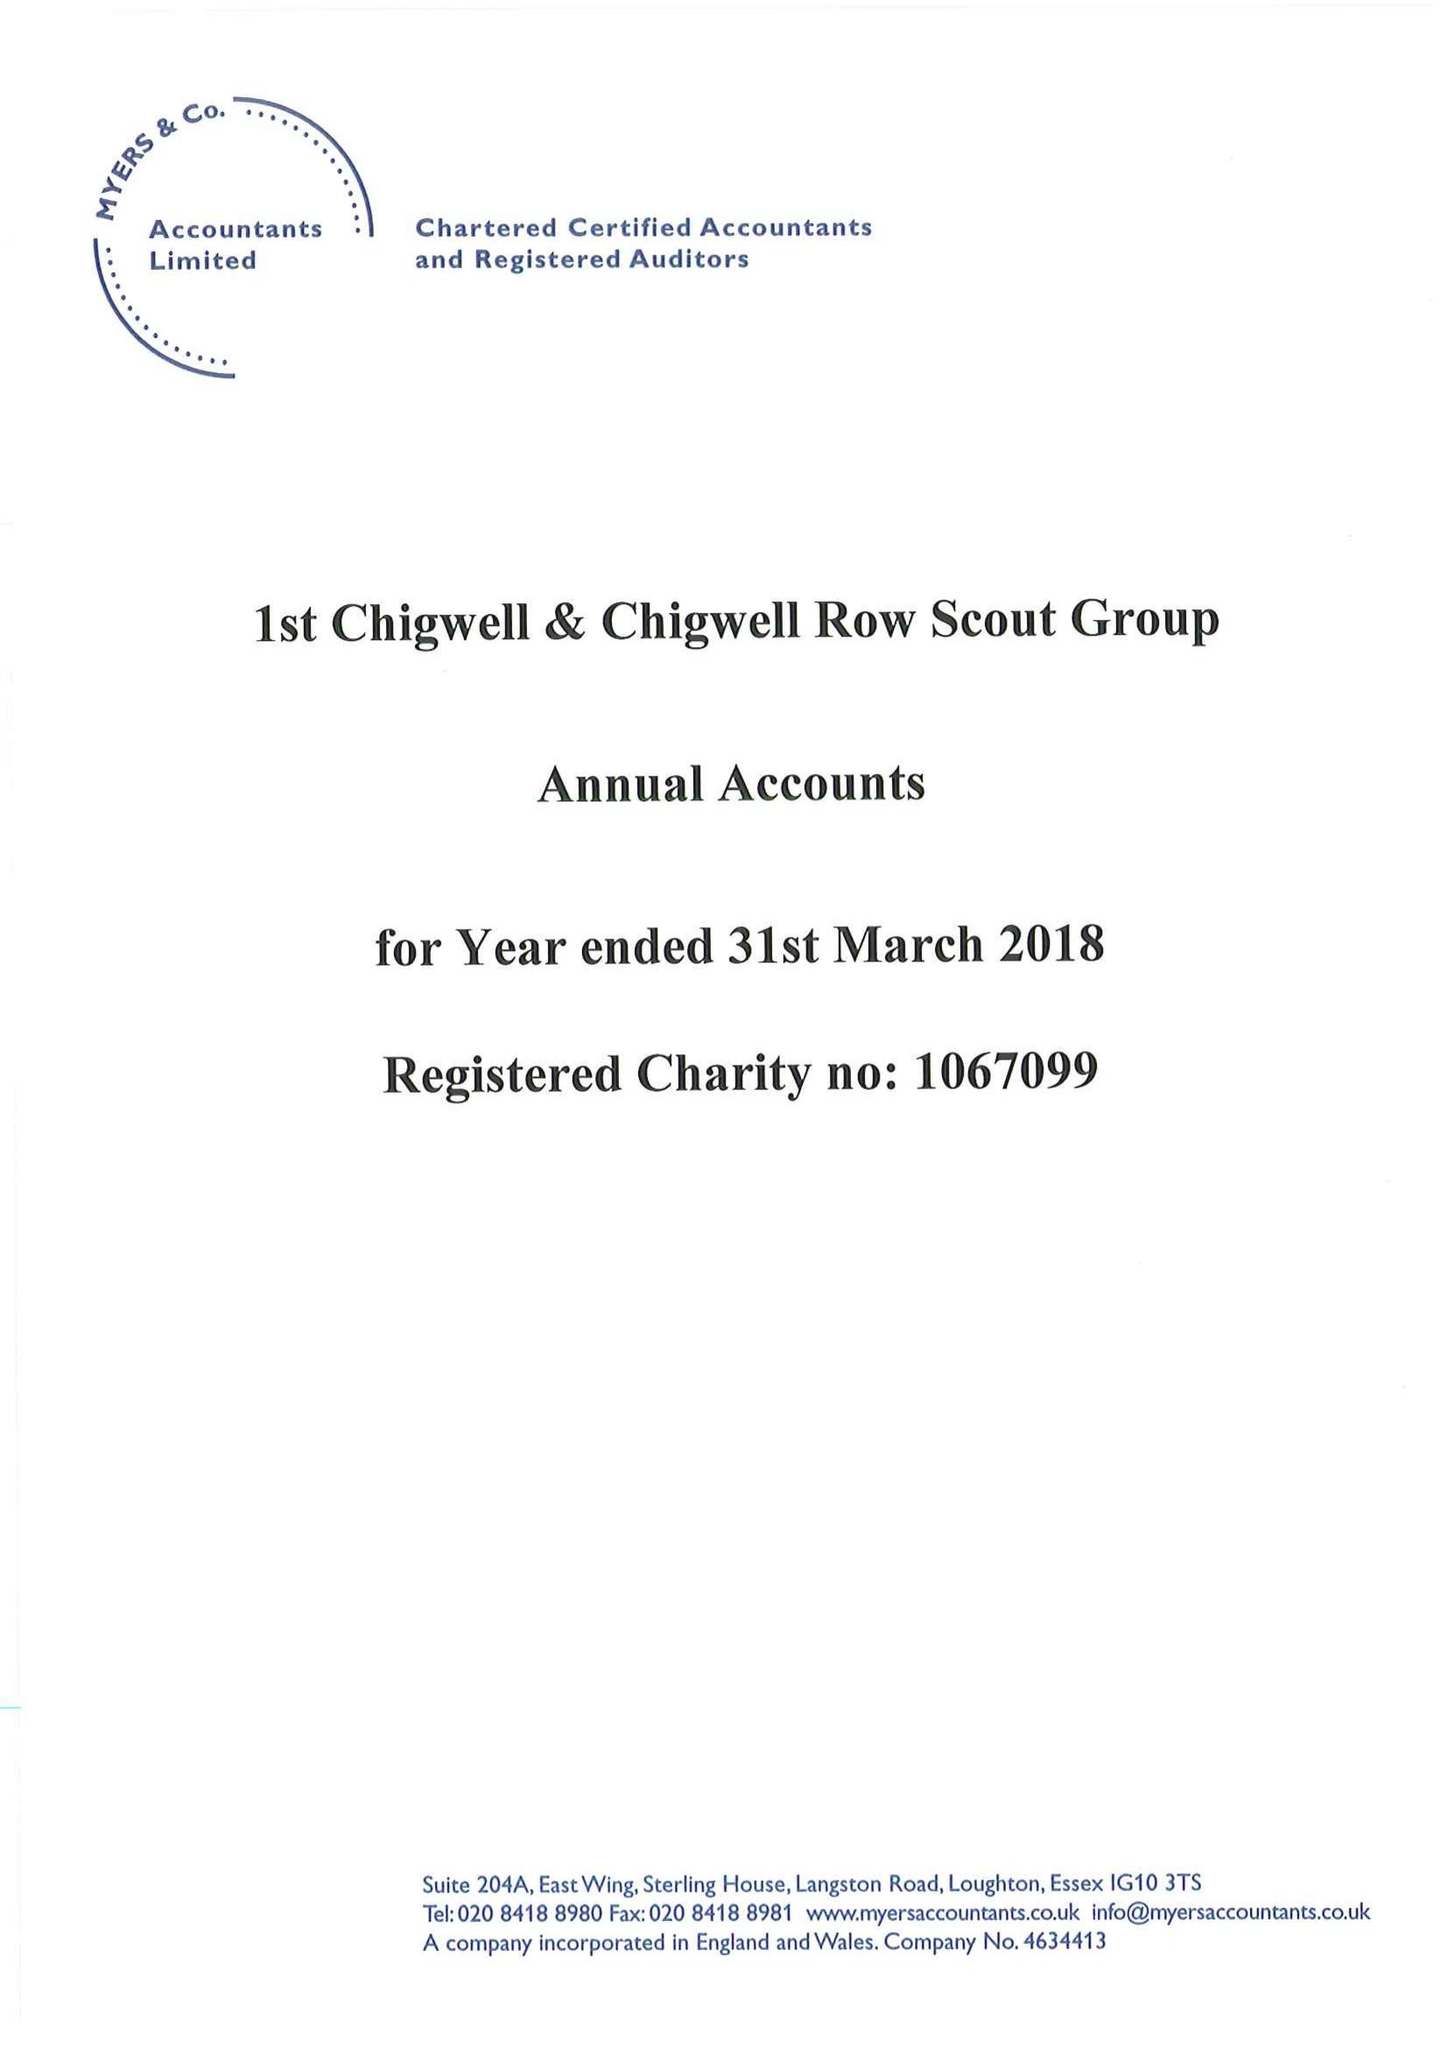What is the value for the spending_annually_in_british_pounds?
Answer the question using a single word or phrase. 25211.00 